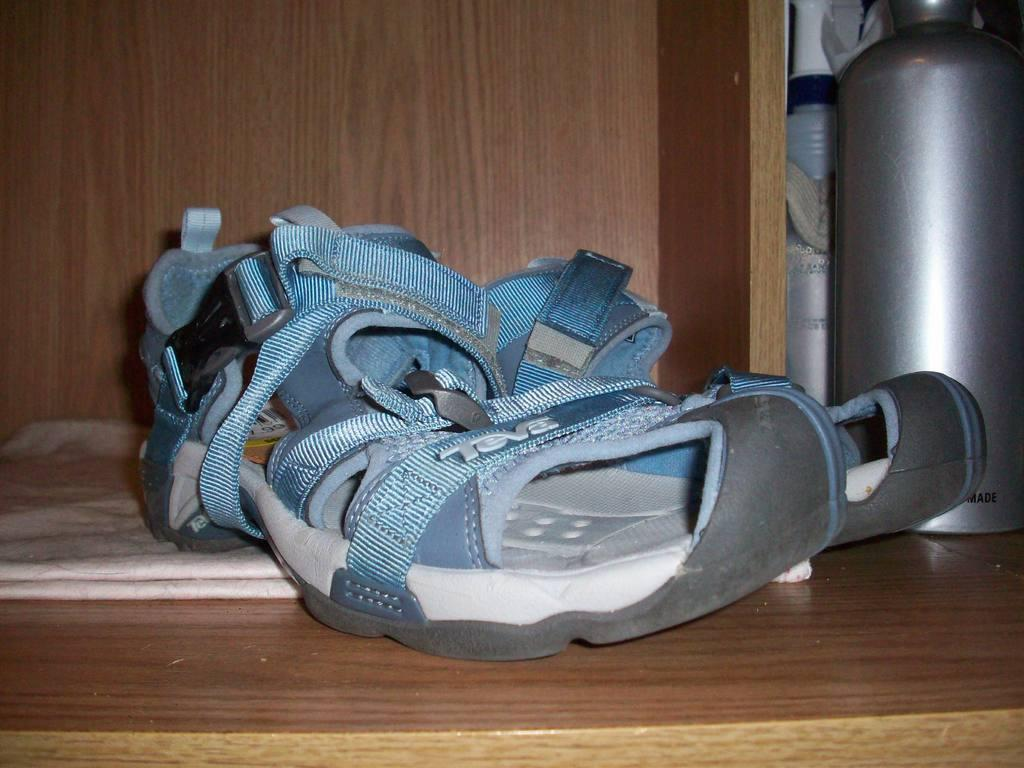What type of footwear is visible in the image? There is a pair of slippers in the image. What surface are the slippers placed on? The slippers are on a wooden surface. What activity is the person with the eye patch doing in the wilderness? There is no person with an eye patch or any wilderness depicted in the image; it only shows a pair of slippers on a wooden surface. 